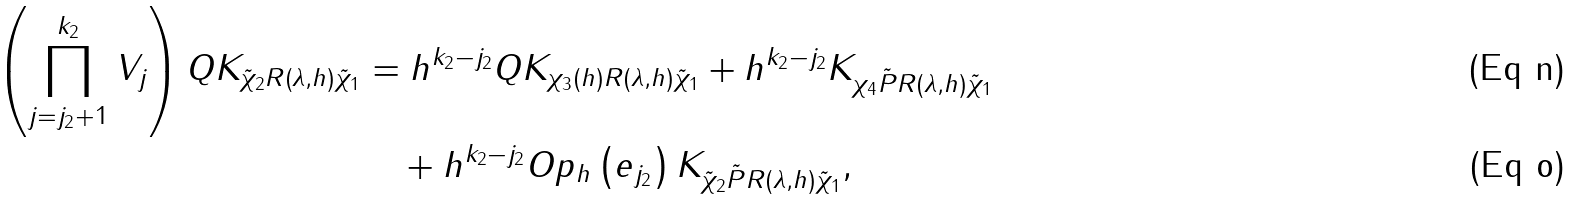<formula> <loc_0><loc_0><loc_500><loc_500>\left ( \prod _ { j = j _ { 2 } + 1 } ^ { k _ { 2 } } V _ { j } \right ) Q K _ { \tilde { \chi } _ { 2 } R \left ( \lambda , h \right ) \tilde { \chi } _ { 1 } } & = h ^ { k _ { 2 } - j _ { 2 } } Q K _ { \chi _ { 3 } ( h ) R ( \lambda , h ) \tilde { \chi } _ { 1 } } + h ^ { k _ { 2 } - j _ { 2 } } K _ { \chi _ { 4 } \tilde { P } R ( \lambda , h ) \tilde { \chi } _ { 1 } } \\ & \quad + h ^ { k _ { 2 } - j _ { 2 } } O p _ { h } \left ( e _ { j _ { 2 } } \right ) K _ { \tilde { \chi } _ { 2 } \tilde { P } R ( \lambda , h ) \tilde { \chi } _ { 1 } } ,</formula> 